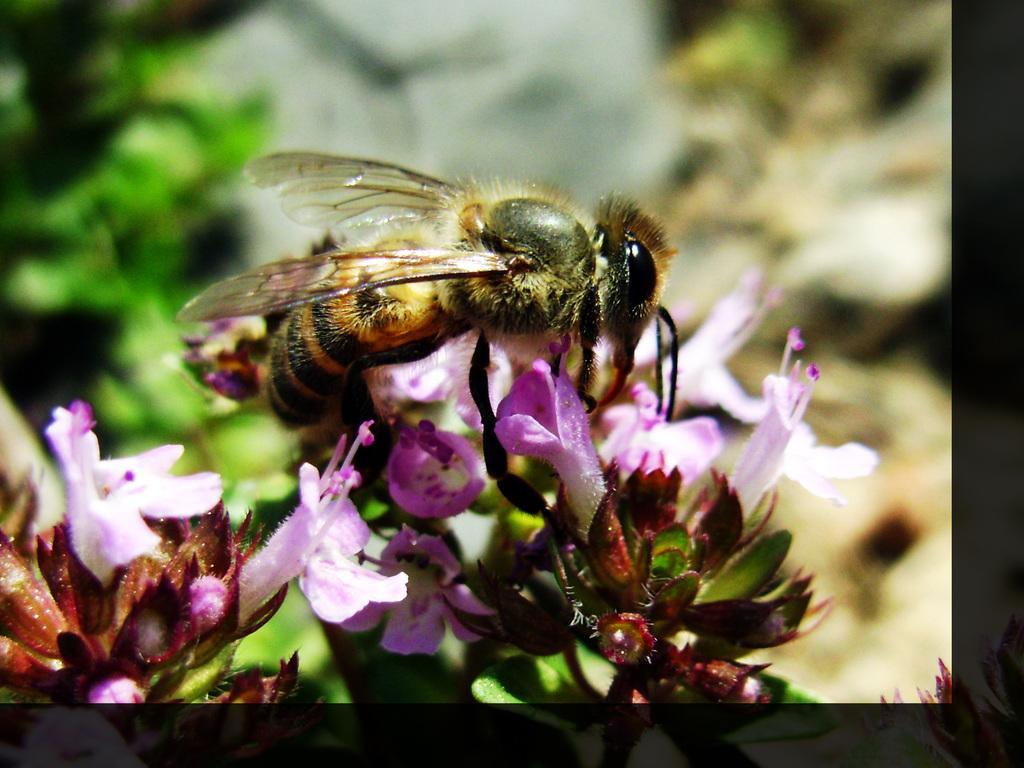Please provide a concise description of this image. In this image I can see an insect which is in black and brown color. It is on the flowers. I can see these flowers are in white and purple color. And there is a blurred background. 